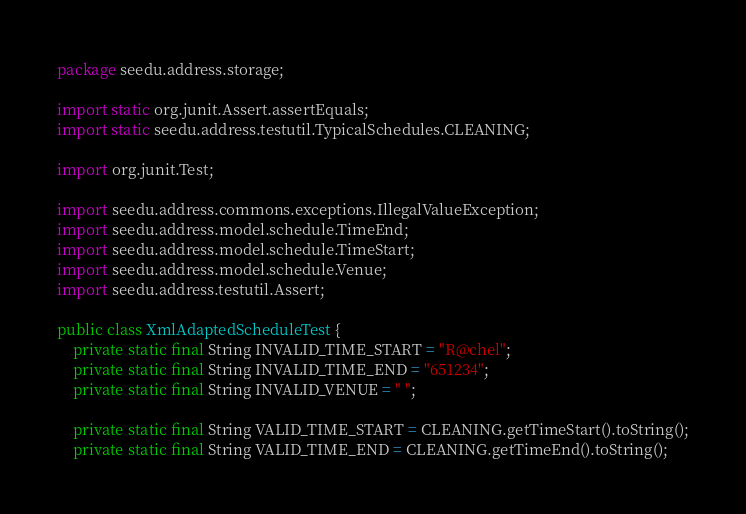<code> <loc_0><loc_0><loc_500><loc_500><_Java_>package seedu.address.storage;

import static org.junit.Assert.assertEquals;
import static seedu.address.testutil.TypicalSchedules.CLEANING;

import org.junit.Test;

import seedu.address.commons.exceptions.IllegalValueException;
import seedu.address.model.schedule.TimeEnd;
import seedu.address.model.schedule.TimeStart;
import seedu.address.model.schedule.Venue;
import seedu.address.testutil.Assert;

public class XmlAdaptedScheduleTest {
    private static final String INVALID_TIME_START = "R@chel";
    private static final String INVALID_TIME_END = "651234";
    private static final String INVALID_VENUE = " ";

    private static final String VALID_TIME_START = CLEANING.getTimeStart().toString();
    private static final String VALID_TIME_END = CLEANING.getTimeEnd().toString();</code> 